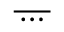<formula> <loc_0><loc_0><loc_500><loc_500>\overline { \, \cdots \, }</formula> 